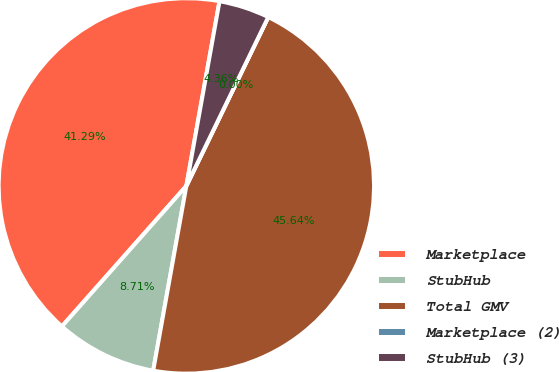Convert chart. <chart><loc_0><loc_0><loc_500><loc_500><pie_chart><fcel>Marketplace<fcel>StubHub<fcel>Total GMV<fcel>Marketplace (2)<fcel>StubHub (3)<nl><fcel>41.29%<fcel>8.71%<fcel>45.64%<fcel>0.0%<fcel>4.36%<nl></chart> 